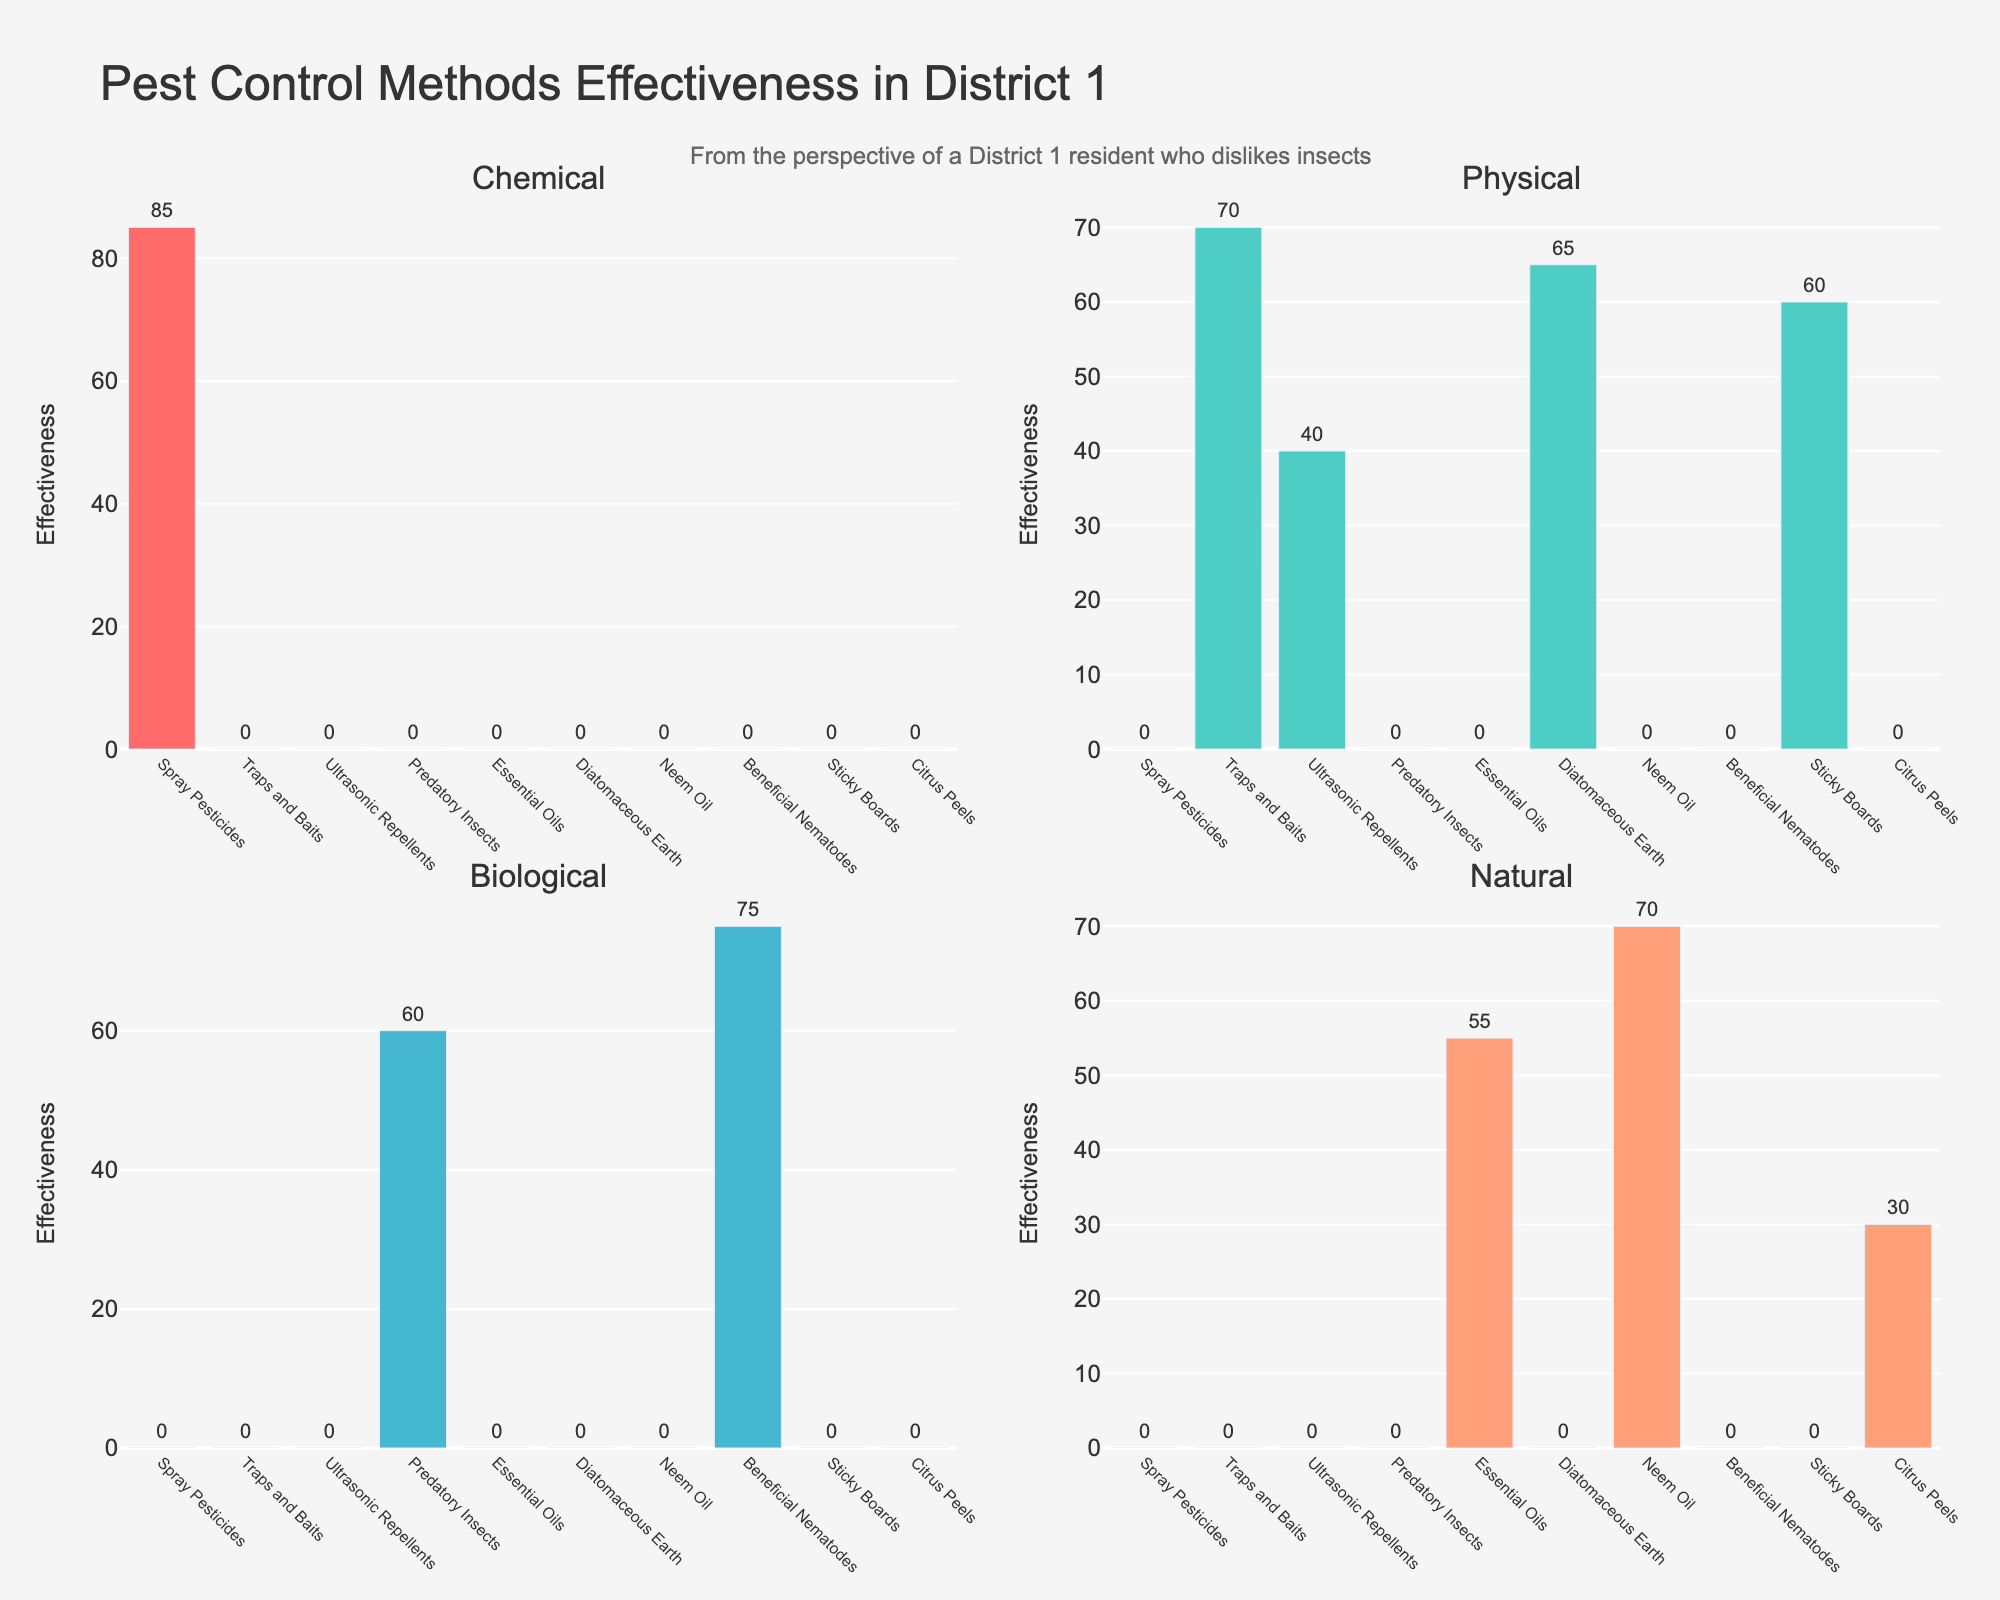What is the title of the figure? The title is usually found at the top of the figure for easy identification and gives a summary of what the figure represents. For this figure, the title is displayed prominently at the top.
Answer: Pest Control Methods Effectiveness in District 1 How many methods of pest control are shown in the figure? To determine this, one would count the number of distinct names on the x-axes of the bar charts in the subplots. Each method name should be unique and listed under each subplot.
Answer: 10 Which pest control method is rated highest for Chemical effectiveness? Look at the Chemical subplot (first subplot) and identify the bar with the highest length. The bar label will indicate the method, and its height indicates the highest rating.
Answer: Spray Pesticides Compare Traps and Baits with Diatomaceous Earth in terms of Physical effectiveness. Which one is more effective? Check the Physical subplot (second subplot) and compare the lengths of the bars for "Traps and Baits" and "Diatomaceous Earth". The longer the bar, the more effective the method.
Answer: Traps and Baits What is the total effectiveness of all pest control methods in the Biological category? Sum the effectiveness ratings in the Biological subplot (third subplot). Add up the values presented on top of each bar: 60 (Predatory Insects) + 75 (Beneficial Nematodes).
Answer: 135 Which pest control method has the highest effectiveness in the Natural category? Look at the Natural subplot (fourth subplot) and identify the bar with the highest length. The bar label will indicate the method, and its height indicates the highest rating.
Answer: Neem Oil Is Ultrasonic Repellents more effective than Sticky Boards in terms of Physical control? Compare the bars for "Ultrasonic Repellents" and "Sticky Boards" in the Physical subplot (second subplot). The one with the higher bar is more effective.
Answer: No Average the effectiveness ratings for Traps and Baits and Diatomaceous Earth in the Physical category. What do you get? Add the effectiveness values of "Traps and Baits" (70) and "Diatomaceous Earth" (65) in the Physical subplot, then divide by 2. (70+65)/2 = 67.5
Answer: 67.5 In the Natural category, which method has the lowest effectiveness and what is its value? Look at the Natural subplot (fourth subplot) and find the bar with the shortest length. The label and height of this bar will indicate the method and its effectiveness.
Answer: Citrus Peels, 30 